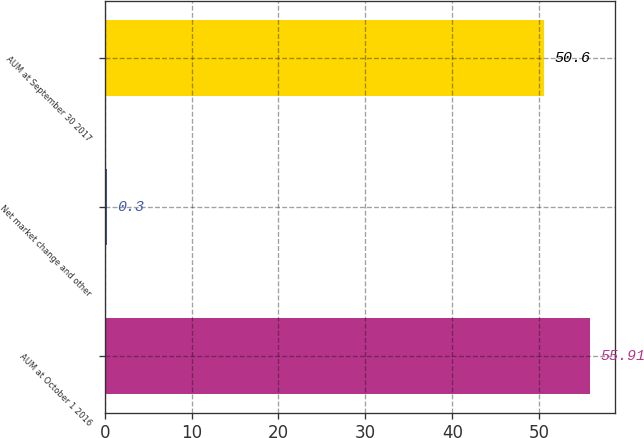<chart> <loc_0><loc_0><loc_500><loc_500><bar_chart><fcel>AUM at October 1 2016<fcel>Net market change and other<fcel>AUM at September 30 2017<nl><fcel>55.91<fcel>0.3<fcel>50.6<nl></chart> 